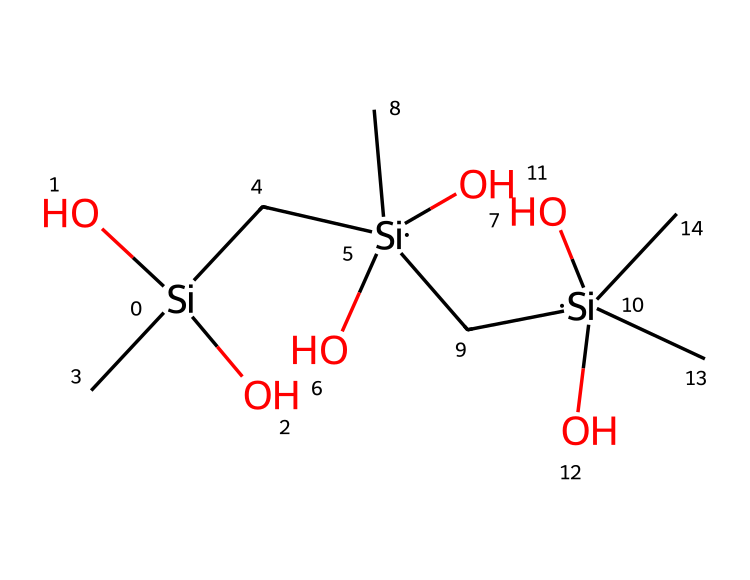What is the central atom in this chemical structure? The chemical structure primarily contains silicon atoms, which are recognizable by their symbol "Si" in the SMILES notation.
Answer: silicon How many silicon atoms are present in the structure? By examining the SMILES, there are three distinct "Si" symbols present, indicating three silicon atoms in the structure.
Answer: three What functional groups are present in this chemical? The chemical structure includes hydroxyl groups (indicated by "O" connected to "Si") and alkyl groups (indicated by "C"). Each silicon atom has two hydroxyl groups and is surrounded by carbon atoms.
Answer: hydroxyl and alkyl What is the probable application of this chemical based on its structure? Given that the structure contains silicon and forms a polymer-like structure with hydroxyl groups, it is indicative of a silicone sealant often used in bathrooms for sealing against moisture.
Answer: sealant Are there any double bonds present in this chemical structure? The SMILES shows single bonds between silicon and both oxygen and carbon atoms, indicating there are no double bonds present.
Answer: no What role does the oxygen atom play in this chemical? The oxygen atoms in the structure act as functional groups that contribute to the properties of silicone sealants, improving adhesion and flexibility.
Answer: functional group What type of chemical is this based on its silicon content? Since the structure prominently features silicon, it can be classified as a silane, which is a type of chemical compound containing silicon.
Answer: silane 